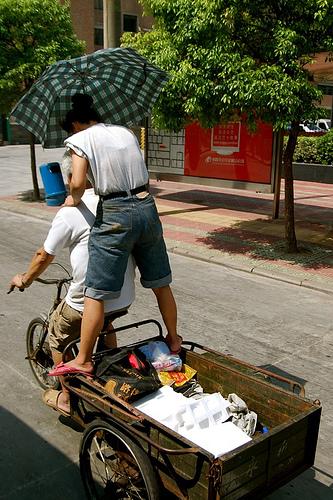Where are the garbage containers?
Write a very short answer. Sidewalk. What is the object in front of the man?
Answer briefly. Umbrella. Does the man have a tattoo on his leg?
Short answer required. No. Is he in danger of falling out?
Short answer required. Yes. How many books are piled?
Write a very short answer. 0. What is the man riding on?
Give a very brief answer. Bike. What is attached to the back of the bike?
Give a very brief answer. Wagon. Is the walking man carrying a shoulder bag?
Give a very brief answer. No. Are the men transporting food?
Write a very short answer. No. Is it raining?
Write a very short answer. No. Is the side of the road neat and tidy?
Give a very brief answer. Yes. 